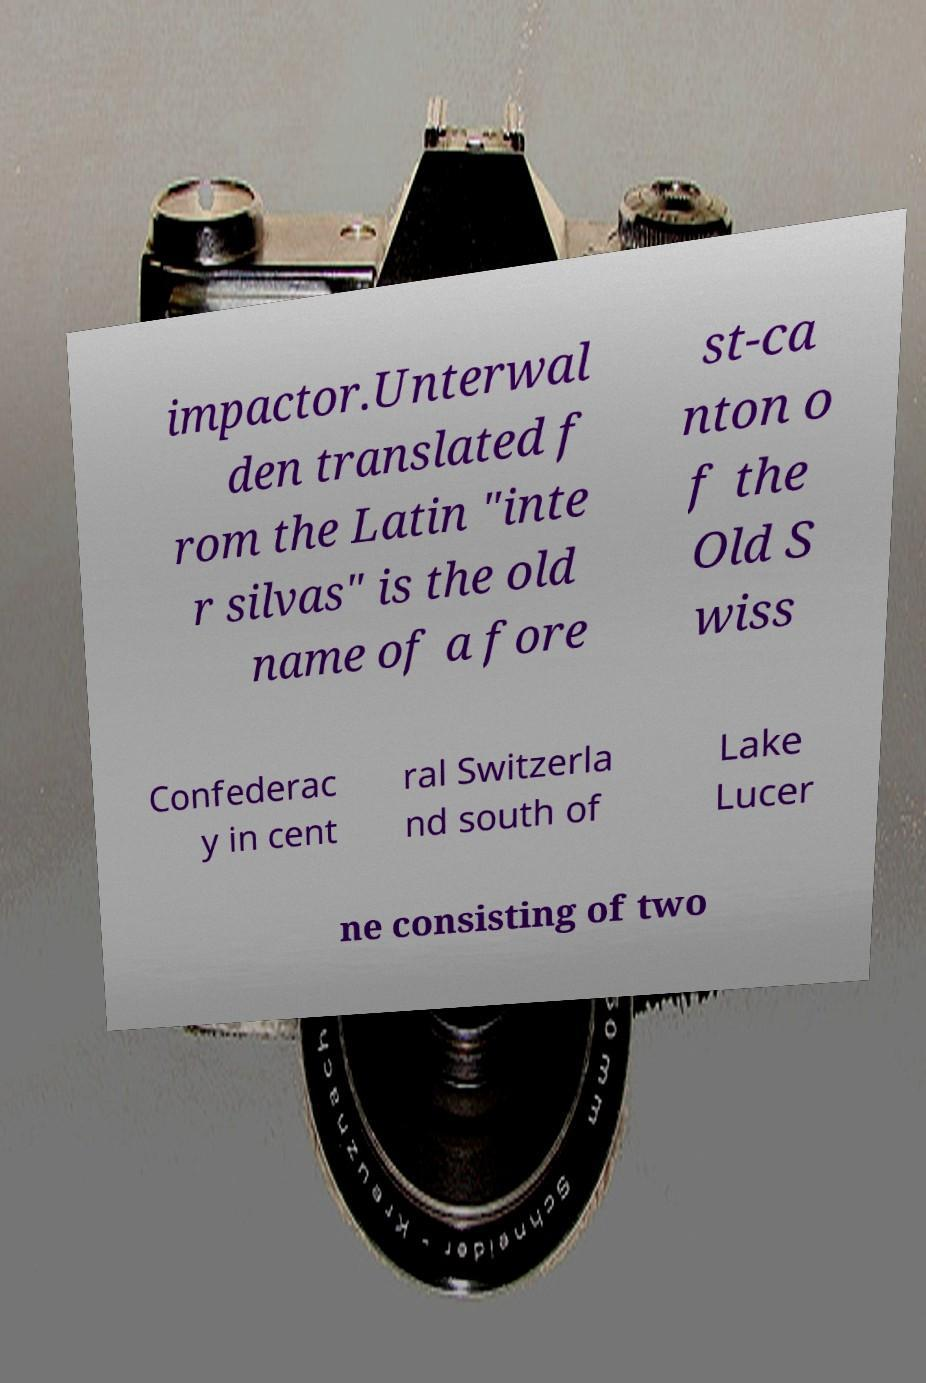Could you extract and type out the text from this image? impactor.Unterwal den translated f rom the Latin "inte r silvas" is the old name of a fore st-ca nton o f the Old S wiss Confederac y in cent ral Switzerla nd south of Lake Lucer ne consisting of two 